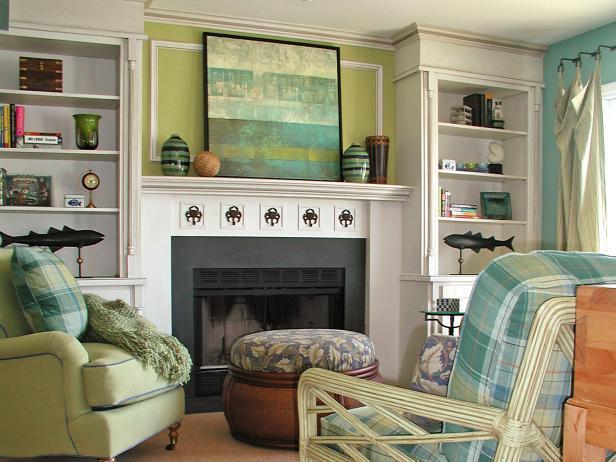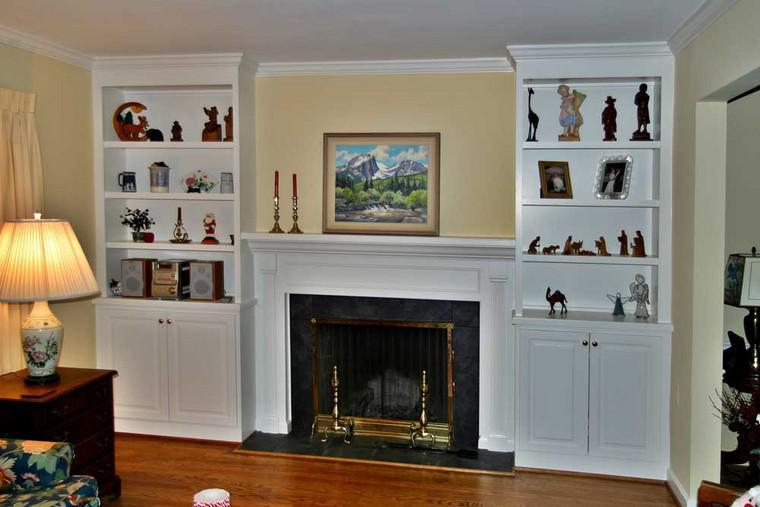The first image is the image on the left, the second image is the image on the right. Analyze the images presented: Is the assertion "One image shows white bookcases with arch shapes above the top shelves, flanking a fireplace that does not have a television mounted above it." valid? Answer yes or no. No. The first image is the image on the left, the second image is the image on the right. For the images shown, is this caption "There are two chair with cream and blue pillows that match the the line painting on the mantle." true? Answer yes or no. Yes. 